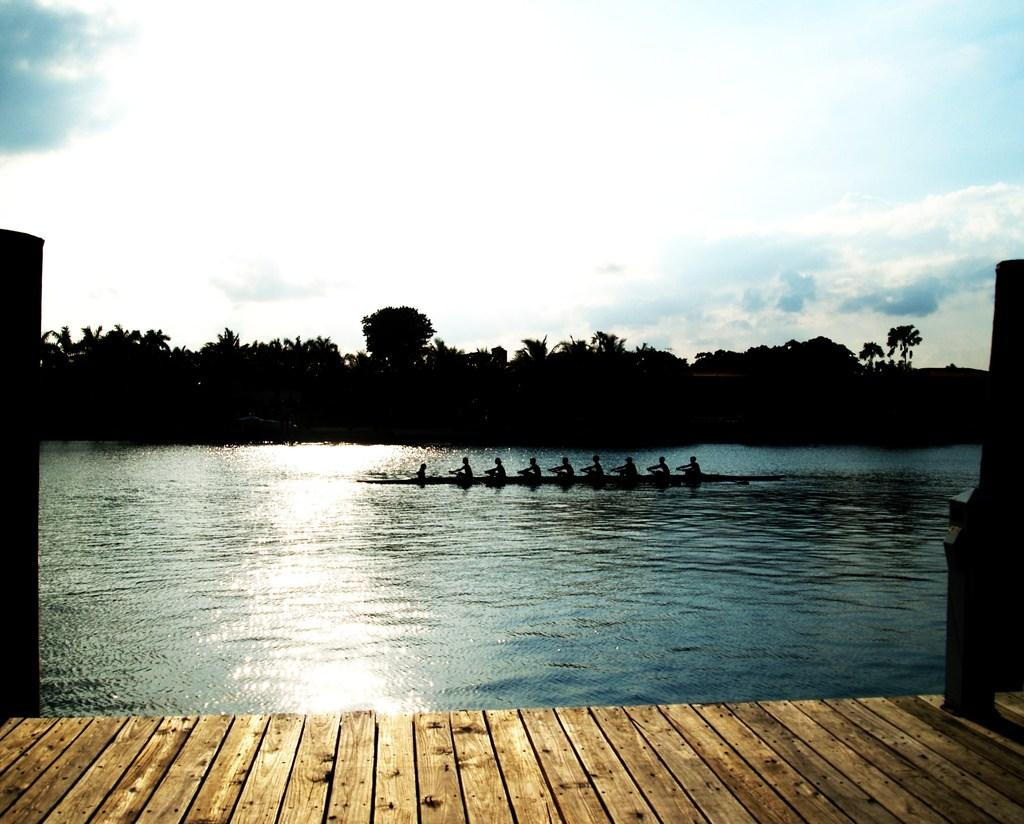What is located in the foreground of the image? There is a dock in the foreground of the image. What can be seen on the water in the image? There are people on a boat in the image. What type of vegetation is visible in the background of the image? There are trees in the background of the image. What is visible in the sky in the image? The sky is visible in the background of the image. Where is the vase located in the image? There is no vase present in the image. What type of maid is serving the people on the boat in the image? There is no maid present in the image; it only shows people on a boat. 